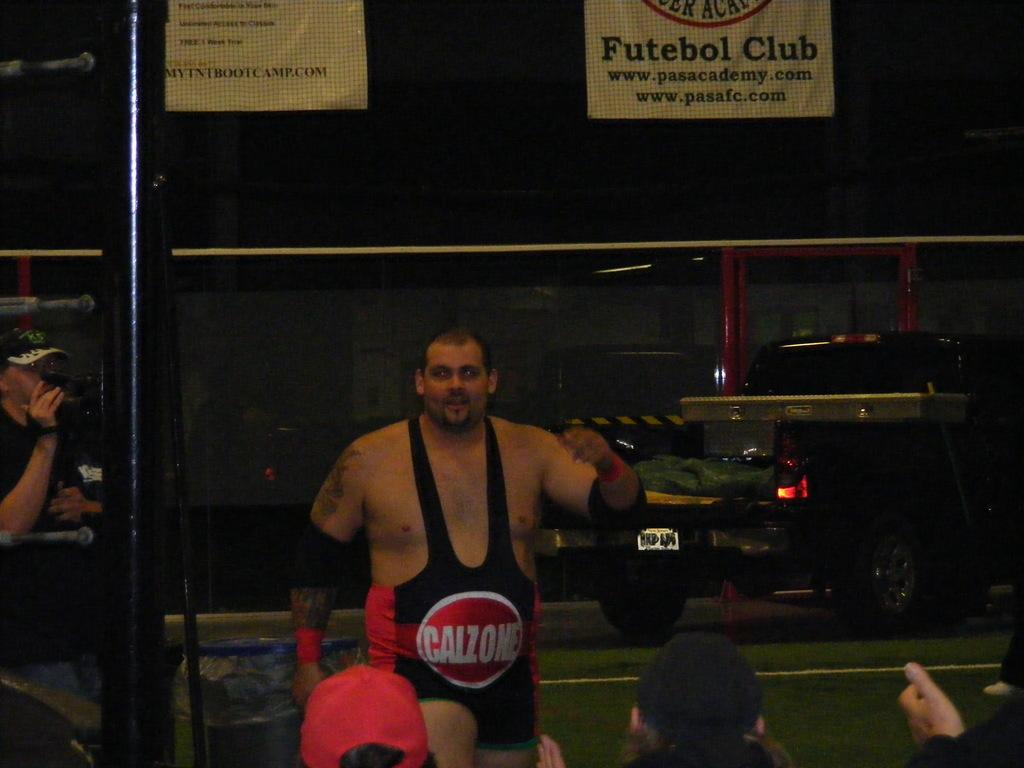<image>
Give a short and clear explanation of the subsequent image. The man is wearing a weightlifter's suit that says Calzone on the belly and he is walking towards a group of people in hats. 